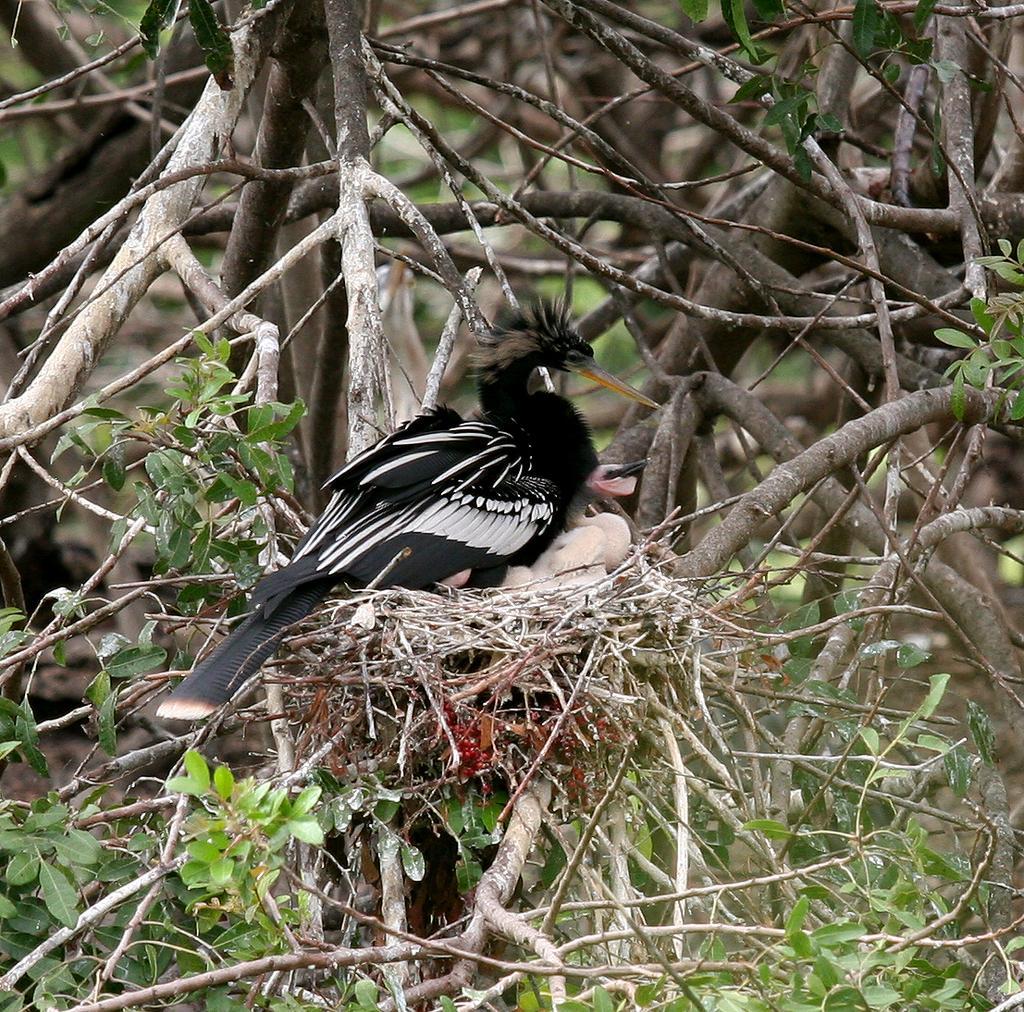Could you give a brief overview of what you see in this image? In this image there are a few birds on the nest, which is on the tree. 